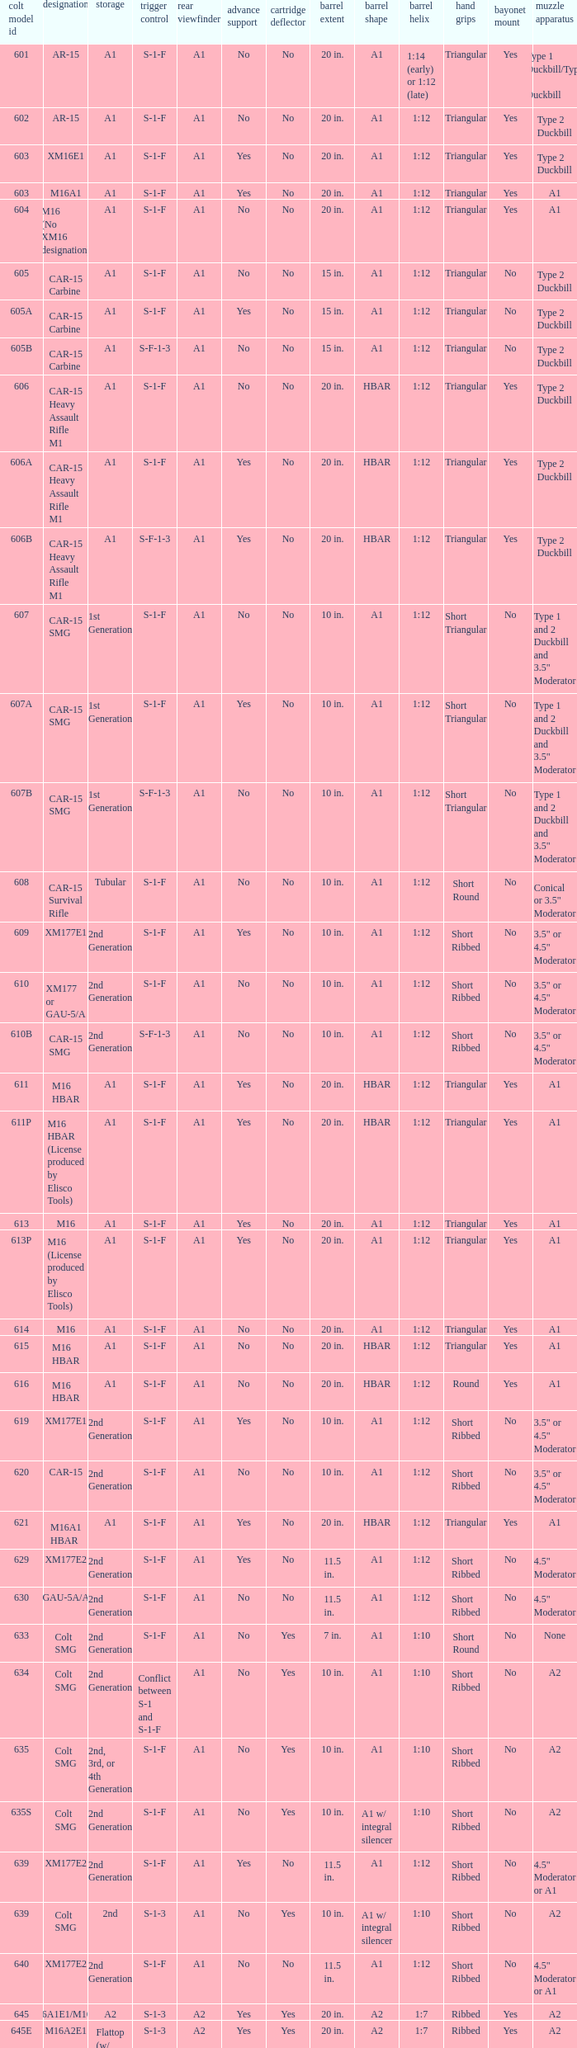Give me the full table as a dictionary. {'header': ['colt model id', 'designation', 'storage', 'trigger control', 'rear viewfinder', 'advance support', 'cartridge deflector', 'barrel extent', 'barrel shape', 'barrel helix', 'hand grips', 'bayonet mount', 'muzzle apparatus'], 'rows': [['601', 'AR-15', 'A1', 'S-1-F', 'A1', 'No', 'No', '20 in.', 'A1', '1:14 (early) or 1:12 (late)', 'Triangular', 'Yes', 'Type 1 Duckbill/Type 2 Duckbill'], ['602', 'AR-15', 'A1', 'S-1-F', 'A1', 'No', 'No', '20 in.', 'A1', '1:12', 'Triangular', 'Yes', 'Type 2 Duckbill'], ['603', 'XM16E1', 'A1', 'S-1-F', 'A1', 'Yes', 'No', '20 in.', 'A1', '1:12', 'Triangular', 'Yes', 'Type 2 Duckbill'], ['603', 'M16A1', 'A1', 'S-1-F', 'A1', 'Yes', 'No', '20 in.', 'A1', '1:12', 'Triangular', 'Yes', 'A1'], ['604', 'M16 (No XM16 designation)', 'A1', 'S-1-F', 'A1', 'No', 'No', '20 in.', 'A1', '1:12', 'Triangular', 'Yes', 'A1'], ['605', 'CAR-15 Carbine', 'A1', 'S-1-F', 'A1', 'No', 'No', '15 in.', 'A1', '1:12', 'Triangular', 'No', 'Type 2 Duckbill'], ['605A', 'CAR-15 Carbine', 'A1', 'S-1-F', 'A1', 'Yes', 'No', '15 in.', 'A1', '1:12', 'Triangular', 'No', 'Type 2 Duckbill'], ['605B', 'CAR-15 Carbine', 'A1', 'S-F-1-3', 'A1', 'No', 'No', '15 in.', 'A1', '1:12', 'Triangular', 'No', 'Type 2 Duckbill'], ['606', 'CAR-15 Heavy Assault Rifle M1', 'A1', 'S-1-F', 'A1', 'No', 'No', '20 in.', 'HBAR', '1:12', 'Triangular', 'Yes', 'Type 2 Duckbill'], ['606A', 'CAR-15 Heavy Assault Rifle M1', 'A1', 'S-1-F', 'A1', 'Yes', 'No', '20 in.', 'HBAR', '1:12', 'Triangular', 'Yes', 'Type 2 Duckbill'], ['606B', 'CAR-15 Heavy Assault Rifle M1', 'A1', 'S-F-1-3', 'A1', 'Yes', 'No', '20 in.', 'HBAR', '1:12', 'Triangular', 'Yes', 'Type 2 Duckbill'], ['607', 'CAR-15 SMG', '1st Generation', 'S-1-F', 'A1', 'No', 'No', '10 in.', 'A1', '1:12', 'Short Triangular', 'No', 'Type 1 and 2 Duckbill and 3.5" Moderator'], ['607A', 'CAR-15 SMG', '1st Generation', 'S-1-F', 'A1', 'Yes', 'No', '10 in.', 'A1', '1:12', 'Short Triangular', 'No', 'Type 1 and 2 Duckbill and 3.5" Moderator'], ['607B', 'CAR-15 SMG', '1st Generation', 'S-F-1-3', 'A1', 'No', 'No', '10 in.', 'A1', '1:12', 'Short Triangular', 'No', 'Type 1 and 2 Duckbill and 3.5" Moderator'], ['608', 'CAR-15 Survival Rifle', 'Tubular', 'S-1-F', 'A1', 'No', 'No', '10 in.', 'A1', '1:12', 'Short Round', 'No', 'Conical or 3.5" Moderator'], ['609', 'XM177E1', '2nd Generation', 'S-1-F', 'A1', 'Yes', 'No', '10 in.', 'A1', '1:12', 'Short Ribbed', 'No', '3.5" or 4.5" Moderator'], ['610', 'XM177 or GAU-5/A', '2nd Generation', 'S-1-F', 'A1', 'No', 'No', '10 in.', 'A1', '1:12', 'Short Ribbed', 'No', '3.5" or 4.5" Moderator'], ['610B', 'CAR-15 SMG', '2nd Generation', 'S-F-1-3', 'A1', 'No', 'No', '10 in.', 'A1', '1:12', 'Short Ribbed', 'No', '3.5" or 4.5" Moderator'], ['611', 'M16 HBAR', 'A1', 'S-1-F', 'A1', 'Yes', 'No', '20 in.', 'HBAR', '1:12', 'Triangular', 'Yes', 'A1'], ['611P', 'M16 HBAR (License produced by Elisco Tools)', 'A1', 'S-1-F', 'A1', 'Yes', 'No', '20 in.', 'HBAR', '1:12', 'Triangular', 'Yes', 'A1'], ['613', 'M16', 'A1', 'S-1-F', 'A1', 'Yes', 'No', '20 in.', 'A1', '1:12', 'Triangular', 'Yes', 'A1'], ['613P', 'M16 (License produced by Elisco Tools)', 'A1', 'S-1-F', 'A1', 'Yes', 'No', '20 in.', 'A1', '1:12', 'Triangular', 'Yes', 'A1'], ['614', 'M16', 'A1', 'S-1-F', 'A1', 'No', 'No', '20 in.', 'A1', '1:12', 'Triangular', 'Yes', 'A1'], ['615', 'M16 HBAR', 'A1', 'S-1-F', 'A1', 'No', 'No', '20 in.', 'HBAR', '1:12', 'Triangular', 'Yes', 'A1'], ['616', 'M16 HBAR', 'A1', 'S-1-F', 'A1', 'No', 'No', '20 in.', 'HBAR', '1:12', 'Round', 'Yes', 'A1'], ['619', 'XM177E1', '2nd Generation', 'S-1-F', 'A1', 'Yes', 'No', '10 in.', 'A1', '1:12', 'Short Ribbed', 'No', '3.5" or 4.5" Moderator'], ['620', 'CAR-15', '2nd Generation', 'S-1-F', 'A1', 'No', 'No', '10 in.', 'A1', '1:12', 'Short Ribbed', 'No', '3.5" or 4.5" Moderator'], ['621', 'M16A1 HBAR', 'A1', 'S-1-F', 'A1', 'Yes', 'No', '20 in.', 'HBAR', '1:12', 'Triangular', 'Yes', 'A1'], ['629', 'XM177E2', '2nd Generation', 'S-1-F', 'A1', 'Yes', 'No', '11.5 in.', 'A1', '1:12', 'Short Ribbed', 'No', '4.5" Moderator'], ['630', 'GAU-5A/A', '2nd Generation', 'S-1-F', 'A1', 'No', 'No', '11.5 in.', 'A1', '1:12', 'Short Ribbed', 'No', '4.5" Moderator'], ['633', 'Colt SMG', '2nd Generation', 'S-1-F', 'A1', 'No', 'Yes', '7 in.', 'A1', '1:10', 'Short Round', 'No', 'None'], ['634', 'Colt SMG', '2nd Generation', 'Conflict between S-1 and S-1-F', 'A1', 'No', 'Yes', '10 in.', 'A1', '1:10', 'Short Ribbed', 'No', 'A2'], ['635', 'Colt SMG', '2nd, 3rd, or 4th Generation', 'S-1-F', 'A1', 'No', 'Yes', '10 in.', 'A1', '1:10', 'Short Ribbed', 'No', 'A2'], ['635S', 'Colt SMG', '2nd Generation', 'S-1-F', 'A1', 'No', 'Yes', '10 in.', 'A1 w/ integral silencer', '1:10', 'Short Ribbed', 'No', 'A2'], ['639', 'XM177E2', '2nd Generation', 'S-1-F', 'A1', 'Yes', 'No', '11.5 in.', 'A1', '1:12', 'Short Ribbed', 'No', '4.5" Moderator or A1'], ['639', 'Colt SMG', '2nd', 'S-1-3', 'A1', 'No', 'Yes', '10 in.', 'A1 w/ integral silencer', '1:10', 'Short Ribbed', 'No', 'A2'], ['640', 'XM177E2', '2nd Generation', 'S-1-F', 'A1', 'No', 'No', '11.5 in.', 'A1', '1:12', 'Short Ribbed', 'No', '4.5" Moderator or A1'], ['645', 'M16A1E1/M16A2', 'A2', 'S-1-3', 'A2', 'Yes', 'Yes', '20 in.', 'A2', '1:7', 'Ribbed', 'Yes', 'A2'], ['645E', 'M16A2E1', 'Flattop (w/ flip down front sight)', 'S-1-3', 'A2', 'Yes', 'Yes', '20 in.', 'A2', '1:7', 'Ribbed', 'Yes', 'A2'], ['646', 'M16A2E3/M16A3', 'A2', 'S-1-F', 'A2', 'Yes', 'Yes', '20 in.', 'A2', '1:7', 'Ribbed', 'Yes', 'A2'], ['649', 'GAU-5A/A', '2nd Generation', 'S-1-F', 'A1', 'No', 'No', '11.5 in.', 'A1', '1:12', 'Short Ribbed', 'No', '4.5" Moderator'], ['650', 'M16A1 carbine', 'A1', 'S-1-F', 'A1', 'Yes', 'No', '14.5 in.', 'A1', '1:12', 'Short Ribbed', 'Yes', 'A1'], ['651', 'M16A1 carbine', 'A1', 'S-1-F', 'A1', 'Yes', 'No', '14.5 in.', 'A1', '1:12', 'Short Ribbed', 'Yes', 'A1'], ['652', 'M16A1 carbine', 'A1', 'S-1-F', 'A1', 'No', 'No', '14.5 in.', 'A1', '1:12', 'Short Ribbed', 'Yes', 'A1'], ['653', 'M16A1 carbine', '2nd Generation', 'S-1-F', 'A1', 'Yes', 'No', '14.5 in.', 'A1', '1:12', 'Short Ribbed', 'Yes', 'A1'], ['653P', 'M16A1 carbine (License produced by Elisco Tools)', '2nd Generation', 'S-1-F', 'A1', 'Yes', 'No', '14.5 in.', 'A1', '1:12', 'Short Ribbed', 'Yes', 'A1'], ['654', 'M16A1 carbine', '2nd Generation', 'S-1-F', 'A1', 'No', 'No', '14.5 in.', 'A1', '1:12', 'Short Ribbed', 'Yes', 'A1'], ['656', 'M16A1 Special Low Profile', 'A1', 'S-1-F', 'Flattop', 'Yes', 'No', '20 in.', 'HBAR', '1:12', 'Triangular', 'Yes', 'A1'], ['701', 'M16A2', 'A2', 'S-1-F', 'A2', 'Yes', 'Yes', '20 in.', 'A2', '1:7', 'Ribbed', 'Yes', 'A2'], ['702', 'M16A2', 'A2', 'S-1-3', 'A2', 'Yes', 'Yes', '20 in.', 'A2', '1:7', 'Ribbed', 'Yes', 'A2'], ['703', 'M16A2', 'A2', 'S-1-F', 'A2', 'Yes', 'Yes', '20 in.', 'A1', '1:7', 'Ribbed', 'Yes', 'A2'], ['705', 'M16A2', 'A2', 'S-1-3', 'A2', 'Yes', 'Yes', '20 in.', 'A2', '1:7', 'Ribbed', 'Yes', 'A2'], ['707', 'M16A2', 'A2', 'S-1-3', 'A2', 'Yes', 'Yes', '20 in.', 'A1', '1:7', 'Ribbed', 'Yes', 'A2'], ['711', 'M16A2', 'A2', 'S-1-F', 'A1', 'Yes', 'No and Yes', '20 in.', 'A1', '1:7', 'Ribbed', 'Yes', 'A2'], ['713', 'M16A2', 'A2', 'S-1-3', 'A2', 'Yes', 'Yes', '20 in.', 'A2', '1:7', 'Ribbed', 'Yes', 'A2'], ['719', 'M16A2', 'A2', 'S-1-3', 'A2', 'Yes', 'Yes', '20 in.', 'A1', '1:7', 'Ribbed', 'Yes', 'A2'], ['720', 'XM4 Carbine', '3rd Generation', 'S-1-3', 'A2', 'Yes', 'Yes', '14.5 in.', 'M4', '1:7', 'Short Ribbed', 'Yes', 'A2'], ['723', 'M16A2 carbine', '3rd Generation', 'S-1-F', 'A1', 'Yes', 'Yes', '14.5 in.', 'A1', '1:7', 'Short Ribbed', 'Yes', 'A1'], ['725A', 'M16A2 carbine', '3rd Generation', 'S-1-F', 'A1', 'Yes', 'Yes', '14.5 in.', 'A1', '1:7', 'Short Ribbed', 'Yes', 'A2'], ['725B', 'M16A2 carbine', '3rd Generation', 'S-1-F', 'A1', 'Yes', 'Yes', '14.5 in.', 'A2', '1:7', 'Short Ribbed', 'Yes', 'A2'], ['726', 'M16A2 carbine', '3rd Generation', 'S-1-F', 'A1', 'Yes', 'Yes', '14.5 in.', 'A1', '1:7', 'Short Ribbed', 'Yes', 'A1'], ['727', 'M16A2 carbine', '3rd Generation', 'S-1-F', 'A2', 'Yes', 'Yes', '14.5 in.', 'M4', '1:7', 'Short Ribbed', 'Yes', 'A2'], ['728', 'M16A2 carbine', '3rd Generation', 'S-1-F', 'A2', 'Yes', 'Yes', '14.5 in.', 'M4', '1:7', 'Short Ribbed', 'Yes', 'A2'], ['733', 'M16A2 Commando / M4 Commando', '3rd or 4th Generation', 'S-1-F', 'A1 or A2', 'Yes', 'Yes or No', '11.5 in.', 'A1 or A2', '1:7', 'Short Ribbed', 'No', 'A1 or A2'], ['733A', 'M16A2 Commando / M4 Commando', '3rd or 4th Generation', 'S-1-3', 'A1 or A2', 'Yes', 'Yes or No', '11.5 in.', 'A1 or A2', '1:7', 'Short Ribbed', 'No', 'A1 or A2'], ['734', 'M16A2 Commando', '3rd Generation', 'S-1-F', 'A1 or A2', 'Yes', 'Yes or No', '11.5 in.', 'A1 or A2', '1:7', 'Short Ribbed', 'No', 'A1 or A2'], ['734A', 'M16A2 Commando', '3rd Generation', 'S-1-3', 'A1 or A2', 'Yes', 'Yes or No', '11.5 in.', 'A1 or A2', '1:7', 'Short Ribbed', 'No', 'A1 or A2'], ['735', 'M16A2 Commando / M4 Commando', '3rd or 4th Generation', 'S-1-3', 'A1 or A2', 'Yes', 'Yes or No', '11.5 in.', 'A1 or A2', '1:7', 'Short Ribbed', 'No', 'A1 or A2'], ['737', 'M16A2', 'A2', 'S-1-3', 'A2', 'Yes', 'Yes', '20 in.', 'HBAR', '1:7', 'Ribbed', 'Yes', 'A2'], ['738', 'M4 Commando Enhanced', '4th Generation', 'S-1-3-F', 'A2', 'Yes', 'Yes', '11.5 in.', 'A2', '1:7', 'Short Ribbed', 'No', 'A1 or A2'], ['741', 'M16A2', 'A2', 'S-1-F', 'A2', 'Yes', 'Yes', '20 in.', 'HBAR', '1:7', 'Ribbed', 'Yes', 'A2'], ['742', 'M16A2 (Standard w/ bipod)', 'A2', 'S-1-F', 'A2', 'Yes', 'Yes', '20 in.', 'HBAR', '1:7', 'Ribbed', 'Yes', 'A2'], ['745', 'M16A2 (Standard w/ bipod)', 'A2', 'S-1-3', 'A2', 'Yes', 'Yes', '20 in.', 'HBAR', '1:7', 'Ribbed', 'Yes', 'A2'], ['746', 'M16A2 (Standard w/ bipod)', 'A2', 'S-1-3', 'A2', 'Yes', 'Yes', '20 in.', 'HBAR', '1:7', 'Ribbed', 'Yes', 'A2'], ['750', 'LMG (Colt/ Diemaco project)', 'A2', 'S-F', 'A2', 'Yes', 'Yes', '20 in.', 'HBAR', '1:7', 'Square LMG', 'Yes', 'A2'], ['777', 'M4 Carbine', '4th Generation', 'S-1-3', 'A2', 'Yes', 'Yes', '14.5 in.', 'M4', '1:7', 'M4', 'Yes', 'A2'], ['778', 'M4 Carbine Enhanced', '4th Generation', 'S-1-3-F', 'A2', 'Yes', 'Yes', '14.5 in.', 'M4', '1:7', 'M4', 'Yes', 'A2'], ['779', 'M4 Carbine', '4th Generation', 'S-1-F', 'A2', 'Yes', 'Yes', '14.5 in.', 'M4', '1:7', 'M4', 'Yes', 'A2'], ['901', 'M16A3', 'A2', 'S-1-F', 'Flattop', 'Yes', 'Yes', '20 in.', 'A2', '1:7', 'Ribbed', 'Yes', 'A2'], ['905', 'M16A4', 'A2', 'S-1-3', 'Flattop', 'Yes', 'Yes', '20 in.', 'A2', '1:7', 'Ribbed', 'Yes', 'A2'], ['920', 'M4 Carbine', '3rd and 4th Generation', 'S-1-3', 'Flattop', 'Yes', 'Yes', '14.5 in.', 'M4', '1:7', 'M4', 'Yes', 'A2'], ['921', 'M4E1/A1 Carbine', '4th Generation', 'S-1-F', 'Flattop', 'Yes', 'Yes', '14.5 in.', 'M4', '1:7', 'M4', 'Yes', 'A2'], ['921HB', 'M4A1 Carbine', '4th Generation', 'S-1-F', 'Flattop', 'Yes', 'Yes', '14.5 in.', 'M4 HBAR', '1:7', 'M4', 'Yes', 'A2'], ['925', 'M4E2 Carbine', '3rd or 4th Generation', 'S-1-3', 'Flattop', 'Yes', 'Yes', '14.5 in.', 'M4', '1:7', 'M4', 'Yes', 'A2'], ['927', 'M4 Carbine', '4th Generation', 'S-1-F', 'Flattop', 'Yes', 'Yes', '14.5 in.', 'M4', '1:7', 'M4', 'Yes', 'A2'], ['933', 'M4 Commando', '4th Generation', 'S-1-F', 'Flattop', 'Yes', 'Yes', '11.5 in.', 'A1 or A2', '1:7', 'Short Ribbed', 'No', 'A2'], ['935', 'M4 Commando', '4th Generation', 'S-1-3', 'Flattop', 'Yes', 'Yes', '11.5 in.', 'A1 or A2', '1:7', 'Short Ribbed', 'No', 'A2'], ['938', 'M4 Commando Enhanced', '4th Generation', 'S-1-3-F', 'Flattop', 'Yes', 'Yes', '11.5 in.', 'A2', '1:7', 'M4', 'No', 'A2'], ['977', 'M4 Carbine', '4th Generation', 'S-1-3', 'Flattop', 'Yes', 'Yes', '14.5 in.', 'M4', '1:7', 'M4', 'Yes', 'A2'], ['941', 'M16A3', 'A2', 'S-1-F', 'Flattop', 'Yes', 'Yes', '20 in.', 'HBAR', '1:7', 'Ribbed', 'Yes', 'A2'], ['942', 'M16A3 (Standard w/ bipod)', 'A2', 'S-1-F', 'Flattop', 'Yes', 'Yes', '20 in.', 'HBAR', '1:7', 'Ribbed', 'Yes', 'A2'], ['945', 'M16A2E4/M16A4', 'A2', 'S-1-3', 'Flattop', 'Yes', 'Yes', '20 in.', 'A2', '1:7', 'Ribbed', 'Yes', 'A2'], ['950', 'LMG (Colt/ Diemaco project)', 'A2', 'S-F', 'Flattop', 'Yes', 'Yes', '20 in.', 'HBAR', '1:7', 'Square LMG', 'Yes', 'A2'], ['"977"', 'M4 Carbine', '4th Generation', 'S-1-3', 'Flattop', 'Yes', 'Yes', '14.5 in.', 'M4', '1:7', 'M4', 'Yes', 'A2'], ['978', 'M4 Carbine Enhanced', '4th Generation', 'S-1-3-F', 'Flattop', 'Yes', 'Yes', '14.5 in.', 'M4', '1:7', 'M4', 'Yes', 'A2'], ['979', 'M4A1 Carbine', '4th Generation', 'S-1-F', 'Flattop', 'Yes', 'Yes', '14.5 in.', 'M4', '1:7', 'M4', 'Yes', 'A2']]} What are the Colt model numbers of the models named GAU-5A/A, with no bayonet lug, no case deflector and stock of 2nd generation?  630, 649. 